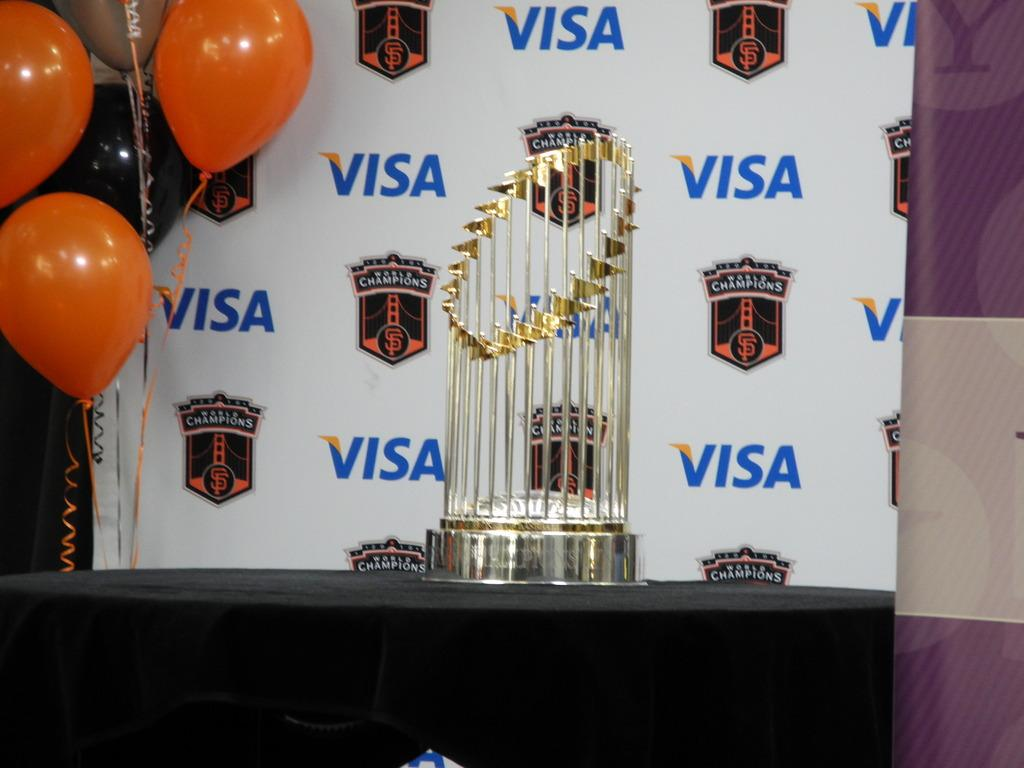What is located at the bottom of the image? There is a table at the bottom of the image. What is on top of the table? There is a cloth and a trophy on the table. What can be seen in the background of the image? There is a wall, a board, and balloons in the background of the image. What type of paste is being used to hold the trophy on the table? There is no paste visible in the image, and the trophy is not shown to be held in place by any adhesive. 